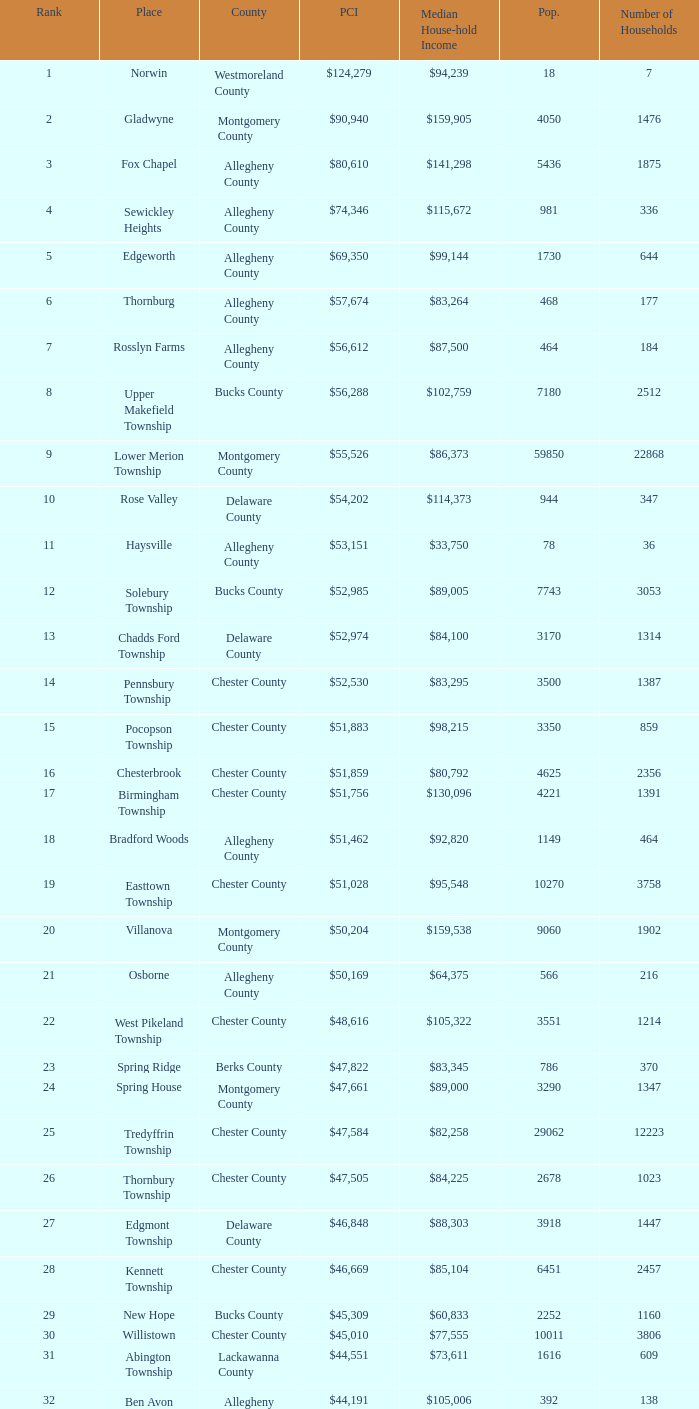What county has 2053 households?  Chester County. 